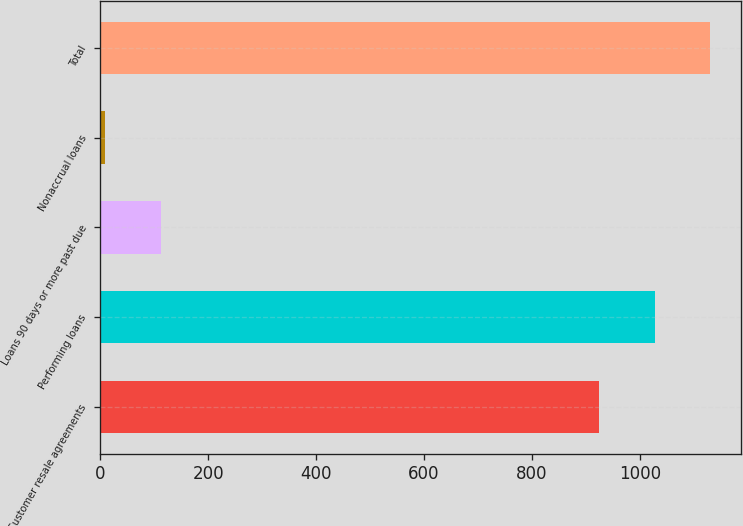Convert chart. <chart><loc_0><loc_0><loc_500><loc_500><bar_chart><fcel>Customer resale agreements<fcel>Performing loans<fcel>Loans 90 days or more past due<fcel>Nonaccrual loans<fcel>Total<nl><fcel>925<fcel>1027.7<fcel>111.7<fcel>9<fcel>1130.4<nl></chart> 